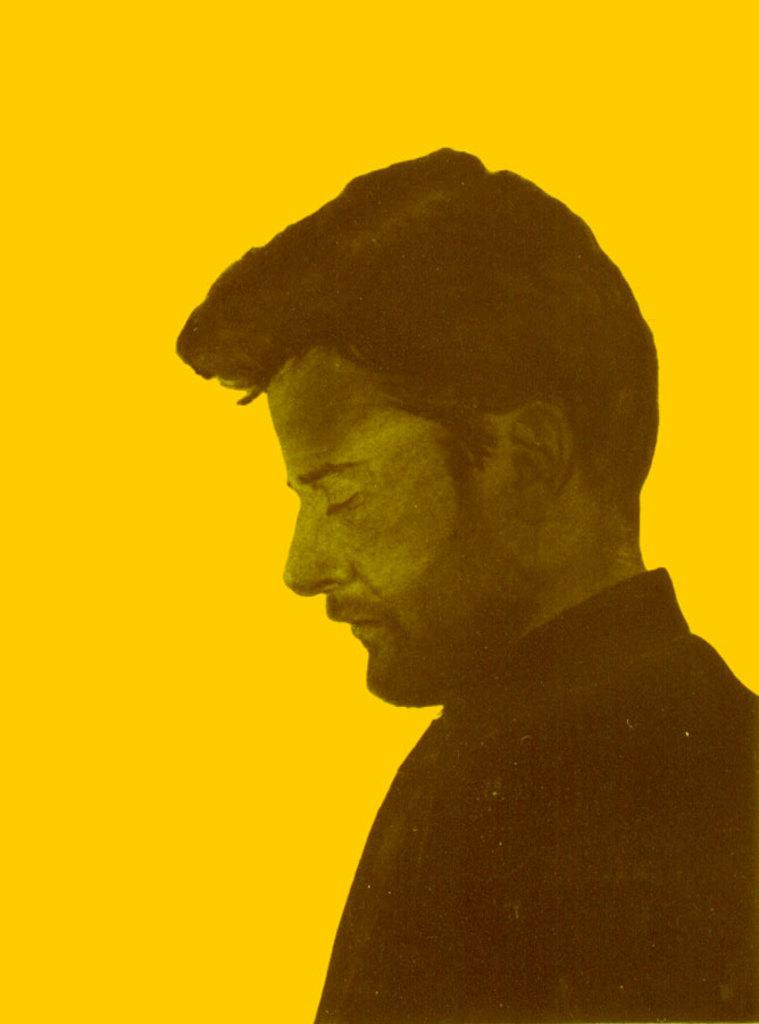What can be observed about the image's appearance? The image is edited. Who is the main subject in the image? There is a picture of a man in the image. What color is the background behind the man? The background behind the man is yellow. What activity is the man engaged in while crying in the image? There is no indication in the image that the man is crying or engaged in any activity. 